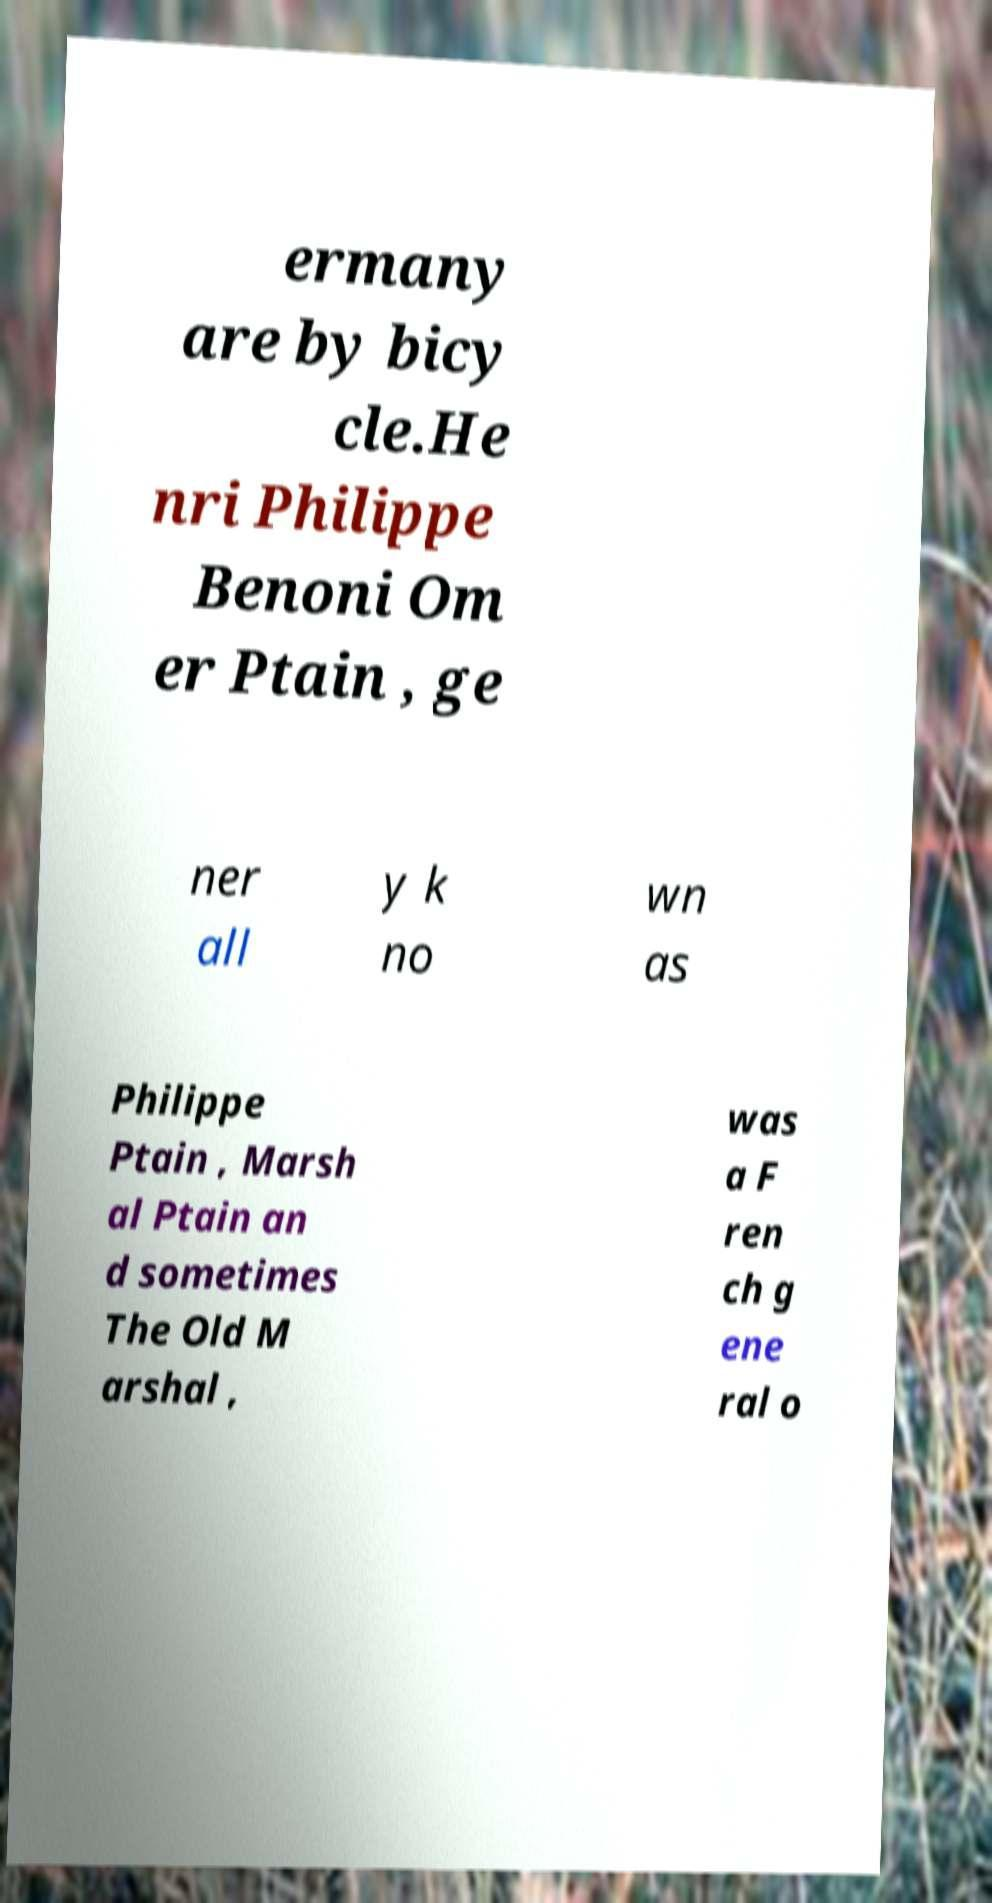What messages or text are displayed in this image? I need them in a readable, typed format. ermany are by bicy cle.He nri Philippe Benoni Om er Ptain , ge ner all y k no wn as Philippe Ptain , Marsh al Ptain an d sometimes The Old M arshal , was a F ren ch g ene ral o 